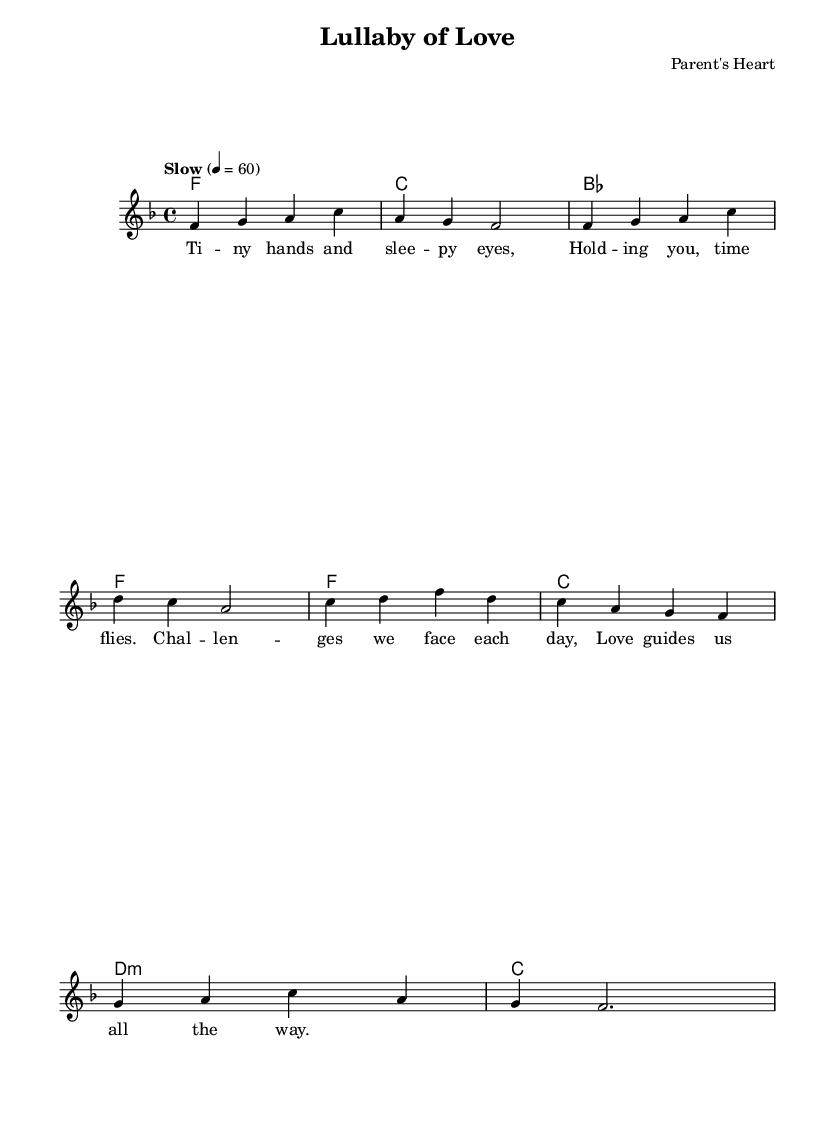What is the key signature of this music? The key signature is F major, which contains one flat (B flat) noted at the beginning of the staff.
Answer: F major What is the time signature of this music? The time signature is 4/4, indicated at the beginning of the staff, which shows four beats per measure.
Answer: 4/4 What is the tempo marking for this piece? The tempo marking states "Slow", with a metronome marking of 60 beats per minute, indicating the speed at which the music should be played.
Answer: Slow How many measures are in the melody section? The melody section contains eight measures, as indicated by the grouping of notes in the staff; each horizontal grouping of notes represents a measure.
Answer: Eight What is the first note of the melody? The first note of the melody is F, which is located on the staff as a note placed on the fourth line.
Answer: F What type of lyrics is provided for this piece? The lyrics are a lullaby, characterized by soothing themes of love and caregiving associated with parenthood, as evident from the title and content.
Answer: Lullaby How do the chords in the harmonies relate to the melody? The chords provide harmonic support to the melody, where each chord matches the melody notes rhythmically, enhancing the overall sound and emotional impact.
Answer: Harmonic support 